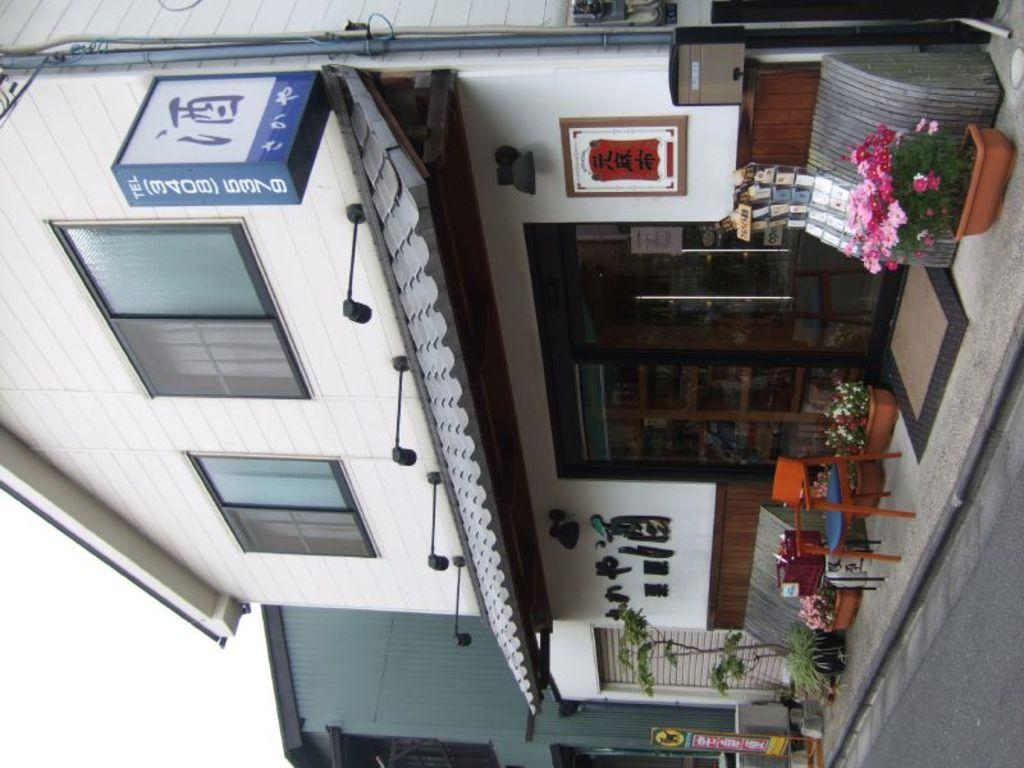What type of structure is visible in the image? There is a building in the image. Where is the road located in the image? The road is in the right bottom corner of the image. What can be seen in front of the building? There are flower pots and a chair in front of the building. What type of science is being conducted in the building in the image? There is no indication of any scientific activity being conducted in the building in the image. 